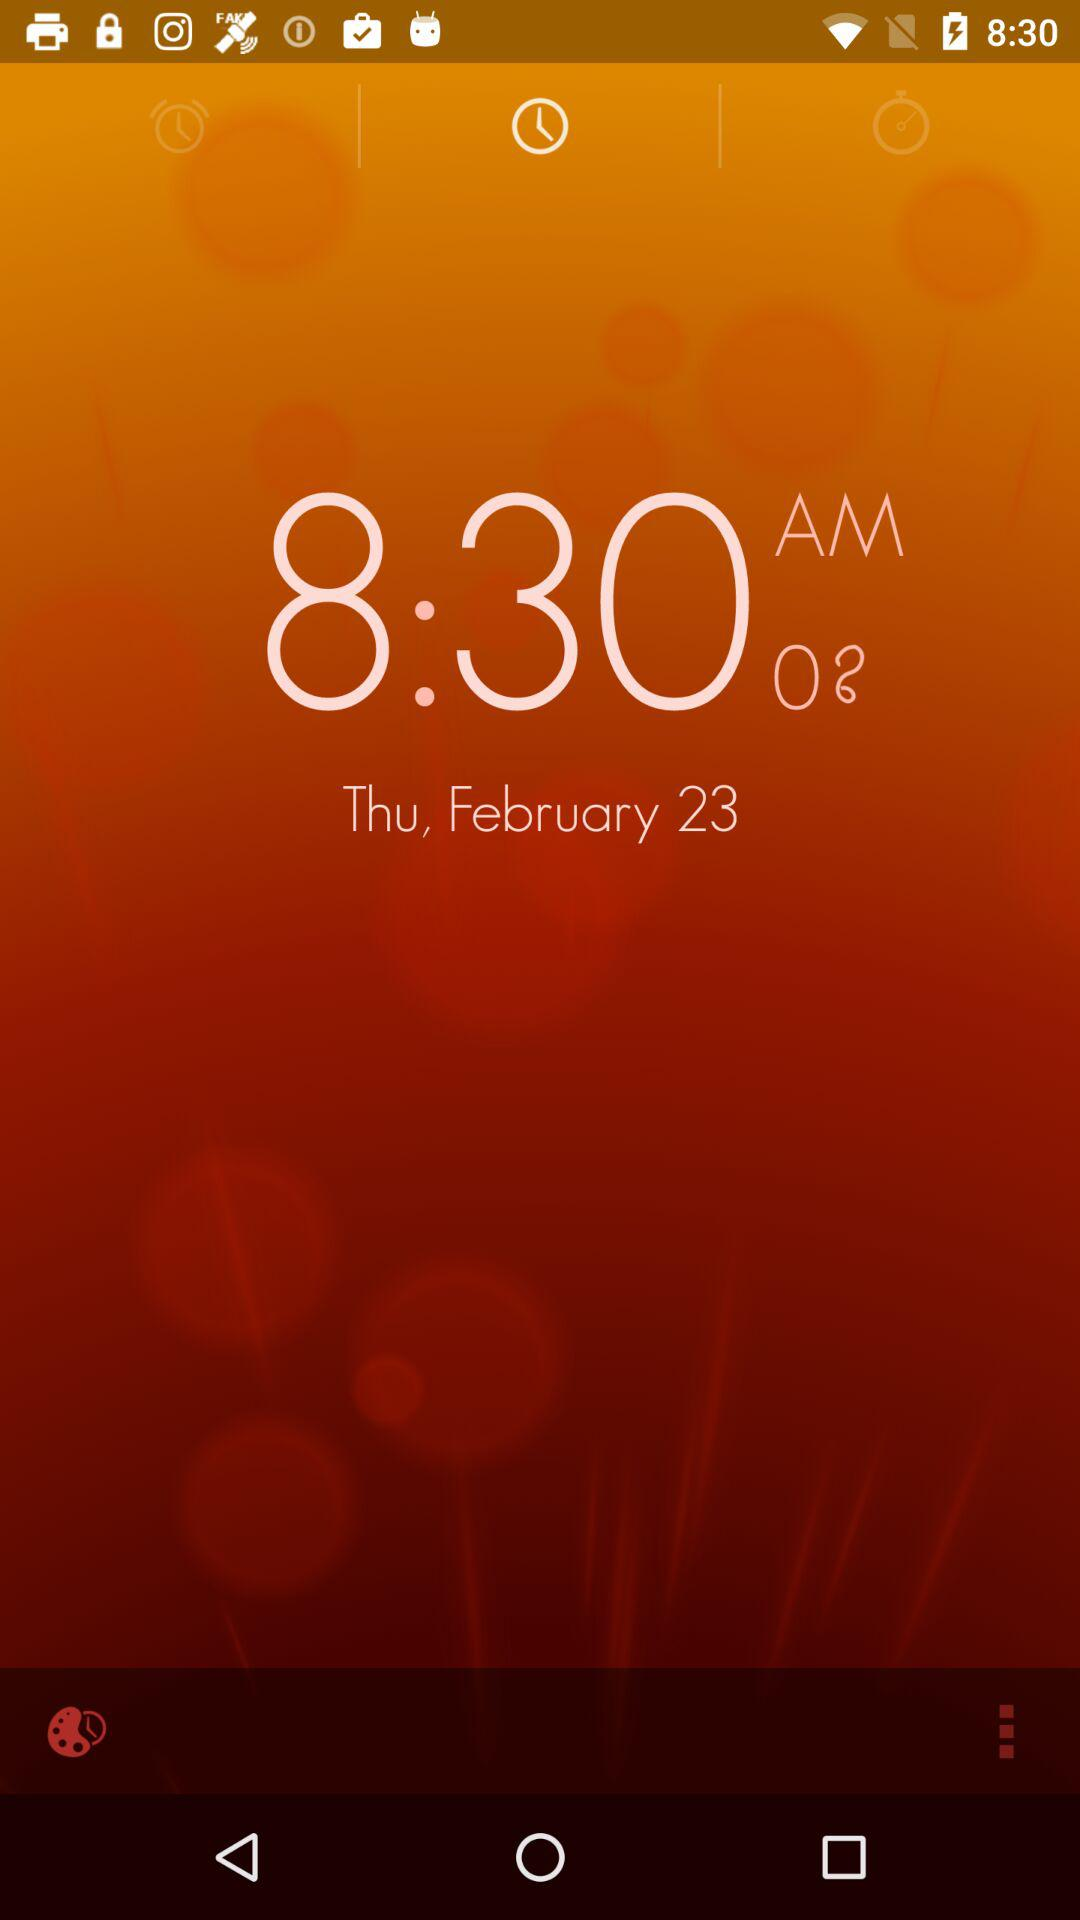What is the current time? The current time is 8:30 am. 